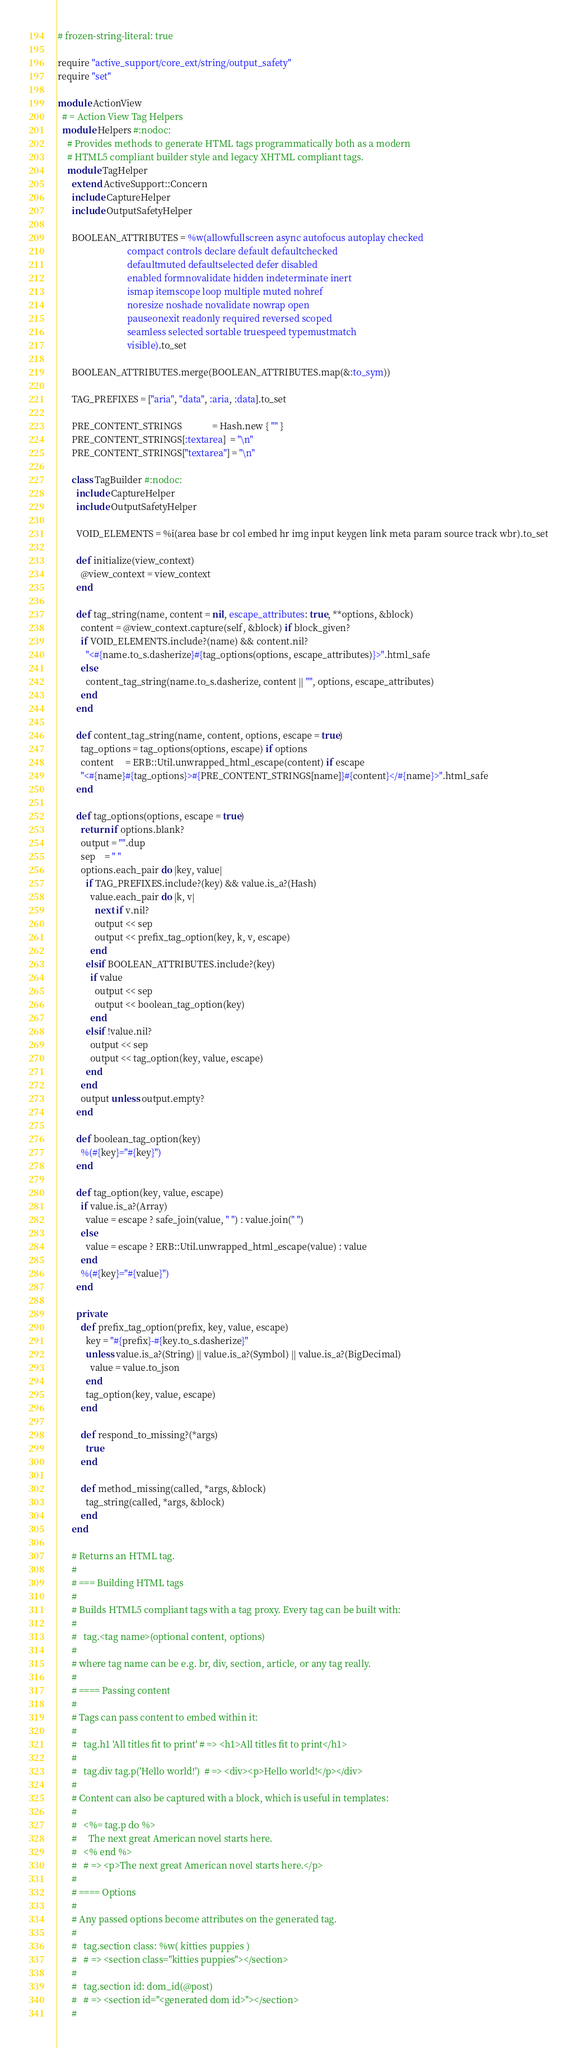Convert code to text. <code><loc_0><loc_0><loc_500><loc_500><_Ruby_># frozen-string-literal: true

require "active_support/core_ext/string/output_safety"
require "set"

module ActionView
  # = Action View Tag Helpers
  module Helpers #:nodoc:
    # Provides methods to generate HTML tags programmatically both as a modern
    # HTML5 compliant builder style and legacy XHTML compliant tags.
    module TagHelper
      extend ActiveSupport::Concern
      include CaptureHelper
      include OutputSafetyHelper

      BOOLEAN_ATTRIBUTES = %w(allowfullscreen async autofocus autoplay checked
                              compact controls declare default defaultchecked
                              defaultmuted defaultselected defer disabled
                              enabled formnovalidate hidden indeterminate inert
                              ismap itemscope loop multiple muted nohref
                              noresize noshade novalidate nowrap open
                              pauseonexit readonly required reversed scoped
                              seamless selected sortable truespeed typemustmatch
                              visible).to_set

      BOOLEAN_ATTRIBUTES.merge(BOOLEAN_ATTRIBUTES.map(&:to_sym))

      TAG_PREFIXES = ["aria", "data", :aria, :data].to_set

      PRE_CONTENT_STRINGS             = Hash.new { "" }
      PRE_CONTENT_STRINGS[:textarea]  = "\n"
      PRE_CONTENT_STRINGS["textarea"] = "\n"

      class TagBuilder #:nodoc:
        include CaptureHelper
        include OutputSafetyHelper

        VOID_ELEMENTS = %i(area base br col embed hr img input keygen link meta param source track wbr).to_set

        def initialize(view_context)
          @view_context = view_context
        end

        def tag_string(name, content = nil, escape_attributes: true, **options, &block)
          content = @view_context.capture(self, &block) if block_given?
          if VOID_ELEMENTS.include?(name) && content.nil?
            "<#{name.to_s.dasherize}#{tag_options(options, escape_attributes)}>".html_safe
          else
            content_tag_string(name.to_s.dasherize, content || "", options, escape_attributes)
          end
        end

        def content_tag_string(name, content, options, escape = true)
          tag_options = tag_options(options, escape) if options
          content     = ERB::Util.unwrapped_html_escape(content) if escape
          "<#{name}#{tag_options}>#{PRE_CONTENT_STRINGS[name]}#{content}</#{name}>".html_safe
        end

        def tag_options(options, escape = true)
          return if options.blank?
          output = "".dup
          sep    = " "
          options.each_pair do |key, value|
            if TAG_PREFIXES.include?(key) && value.is_a?(Hash)
              value.each_pair do |k, v|
                next if v.nil?
                output << sep
                output << prefix_tag_option(key, k, v, escape)
              end
            elsif BOOLEAN_ATTRIBUTES.include?(key)
              if value
                output << sep
                output << boolean_tag_option(key)
              end
            elsif !value.nil?
              output << sep
              output << tag_option(key, value, escape)
            end
          end
          output unless output.empty?
        end

        def boolean_tag_option(key)
          %(#{key}="#{key}")
        end

        def tag_option(key, value, escape)
          if value.is_a?(Array)
            value = escape ? safe_join(value, " ") : value.join(" ")
          else
            value = escape ? ERB::Util.unwrapped_html_escape(value) : value
          end
          %(#{key}="#{value}")
        end

        private
          def prefix_tag_option(prefix, key, value, escape)
            key = "#{prefix}-#{key.to_s.dasherize}"
            unless value.is_a?(String) || value.is_a?(Symbol) || value.is_a?(BigDecimal)
              value = value.to_json
            end
            tag_option(key, value, escape)
          end

          def respond_to_missing?(*args)
            true
          end

          def method_missing(called, *args, &block)
            tag_string(called, *args, &block)
          end
      end

      # Returns an HTML tag.
      #
      # === Building HTML tags
      #
      # Builds HTML5 compliant tags with a tag proxy. Every tag can be built with:
      #
      #   tag.<tag name>(optional content, options)
      #
      # where tag name can be e.g. br, div, section, article, or any tag really.
      #
      # ==== Passing content
      #
      # Tags can pass content to embed within it:
      #
      #   tag.h1 'All titles fit to print' # => <h1>All titles fit to print</h1>
      #
      #   tag.div tag.p('Hello world!')  # => <div><p>Hello world!</p></div>
      #
      # Content can also be captured with a block, which is useful in templates:
      #
      #   <%= tag.p do %>
      #     The next great American novel starts here.
      #   <% end %>
      #   # => <p>The next great American novel starts here.</p>
      #
      # ==== Options
      #
      # Any passed options become attributes on the generated tag.
      #
      #   tag.section class: %w( kitties puppies )
      #   # => <section class="kitties puppies"></section>
      #
      #   tag.section id: dom_id(@post)
      #   # => <section id="<generated dom id>"></section>
      #</code> 